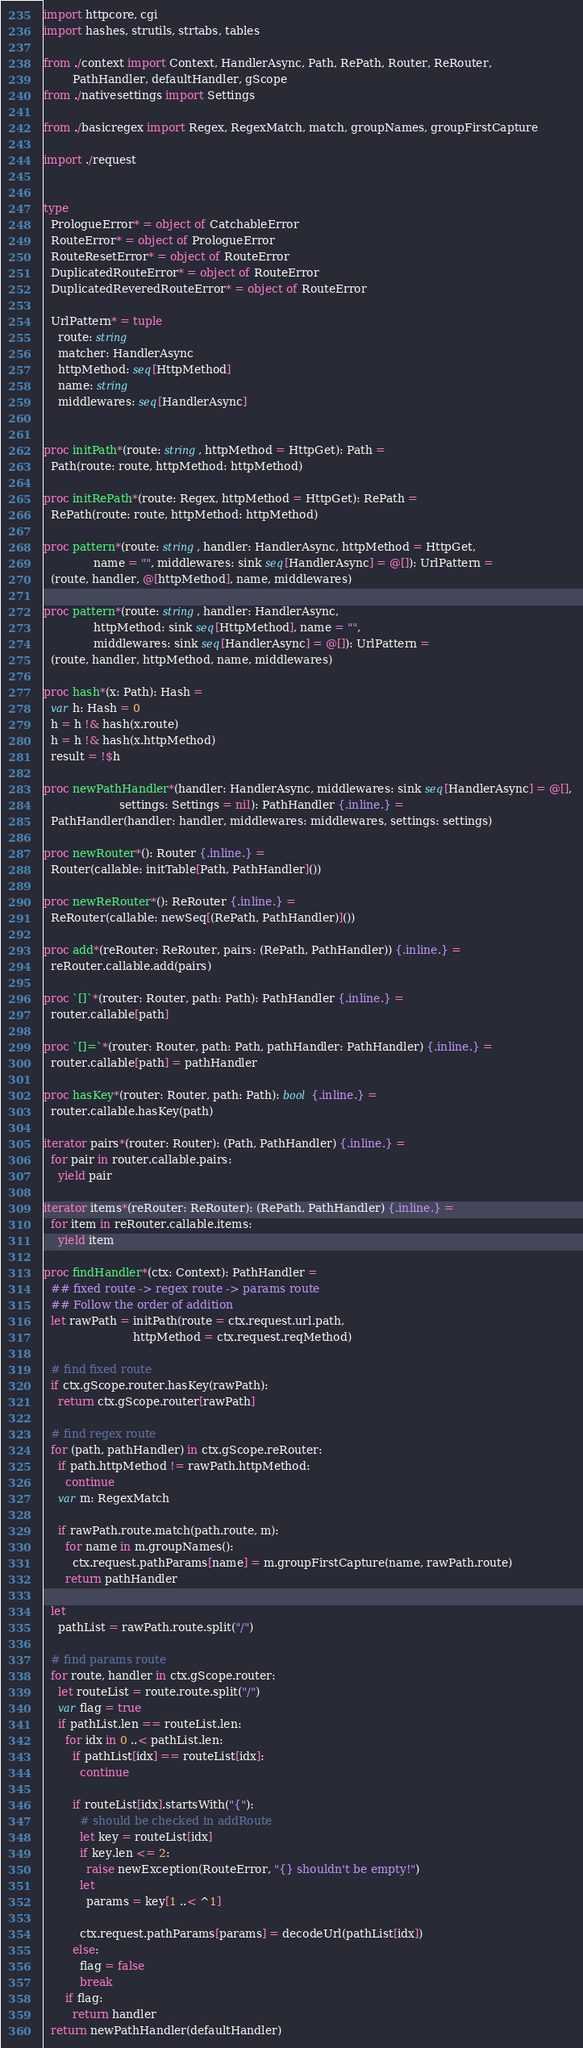<code> <loc_0><loc_0><loc_500><loc_500><_Nim_>import httpcore, cgi
import hashes, strutils, strtabs, tables

from ./context import Context, HandlerAsync, Path, RePath, Router, ReRouter,
        PathHandler, defaultHandler, gScope
from ./nativesettings import Settings

from ./basicregex import Regex, RegexMatch, match, groupNames, groupFirstCapture

import ./request


type
  PrologueError* = object of CatchableError
  RouteError* = object of PrologueError
  RouteResetError* = object of RouteError
  DuplicatedRouteError* = object of RouteError
  DuplicatedReveredRouteError* = object of RouteError

  UrlPattern* = tuple
    route: string
    matcher: HandlerAsync
    httpMethod: seq[HttpMethod]
    name: string
    middlewares: seq[HandlerAsync]


proc initPath*(route: string, httpMethod = HttpGet): Path =
  Path(route: route, httpMethod: httpMethod)

proc initRePath*(route: Regex, httpMethod = HttpGet): RePath =
  RePath(route: route, httpMethod: httpMethod)

proc pattern*(route: string, handler: HandlerAsync, httpMethod = HttpGet,
              name = "", middlewares: sink seq[HandlerAsync] = @[]): UrlPattern =
  (route, handler, @[httpMethod], name, middlewares)

proc pattern*(route: string, handler: HandlerAsync, 
              httpMethod: sink seq[HttpMethod], name = "", 
              middlewares: sink seq[HandlerAsync] = @[]): UrlPattern =
  (route, handler, httpMethod, name, middlewares)

proc hash*(x: Path): Hash =
  var h: Hash = 0
  h = h !& hash(x.route)
  h = h !& hash(x.httpMethod)
  result = !$h

proc newPathHandler*(handler: HandlerAsync, middlewares: sink seq[HandlerAsync] = @[], 
                     settings: Settings = nil): PathHandler {.inline.} =
  PathHandler(handler: handler, middlewares: middlewares, settings: settings)

proc newRouter*(): Router {.inline.} =
  Router(callable: initTable[Path, PathHandler]())

proc newReRouter*(): ReRouter {.inline.} =
  ReRouter(callable: newSeq[(RePath, PathHandler)]())

proc add*(reRouter: ReRouter, pairs: (RePath, PathHandler)) {.inline.} =
  reRouter.callable.add(pairs)

proc `[]`*(router: Router, path: Path): PathHandler {.inline.} =
  router.callable[path]

proc `[]=`*(router: Router, path: Path, pathHandler: PathHandler) {.inline.} =
  router.callable[path] = pathHandler

proc hasKey*(router: Router, path: Path): bool {.inline.} =
  router.callable.hasKey(path)

iterator pairs*(router: Router): (Path, PathHandler) {.inline.} =
  for pair in router.callable.pairs:
    yield pair

iterator items*(reRouter: ReRouter): (RePath, PathHandler) {.inline.} =
  for item in reRouter.callable.items:
    yield item

proc findHandler*(ctx: Context): PathHandler =
  ## fixed route -> regex route -> params route
  ## Follow the order of addition
  let rawPath = initPath(route = ctx.request.url.path,
                         httpMethod = ctx.request.reqMethod)

  # find fixed route
  if ctx.gScope.router.hasKey(rawPath):
    return ctx.gScope.router[rawPath]

  # find regex route
  for (path, pathHandler) in ctx.gScope.reRouter:
    if path.httpMethod != rawPath.httpMethod:
      continue
    var m: RegexMatch

    if rawPath.route.match(path.route, m):
      for name in m.groupNames():
        ctx.request.pathParams[name] = m.groupFirstCapture(name, rawPath.route)
      return pathHandler

  let
    pathList = rawPath.route.split("/")

  # find params route
  for route, handler in ctx.gScope.router:
    let routeList = route.route.split("/")
    var flag = true
    if pathList.len == routeList.len:
      for idx in 0 ..< pathList.len:
        if pathList[idx] == routeList[idx]:
          continue

        if routeList[idx].startsWith("{"):
          # should be checked in addRoute
          let key = routeList[idx]
          if key.len <= 2:
            raise newException(RouteError, "{} shouldn't be empty!")
          let
            params = key[1 ..< ^1]

          ctx.request.pathParams[params] = decodeUrl(pathList[idx])
        else:
          flag = false
          break
      if flag:
        return handler
  return newPathHandler(defaultHandler)
</code> 